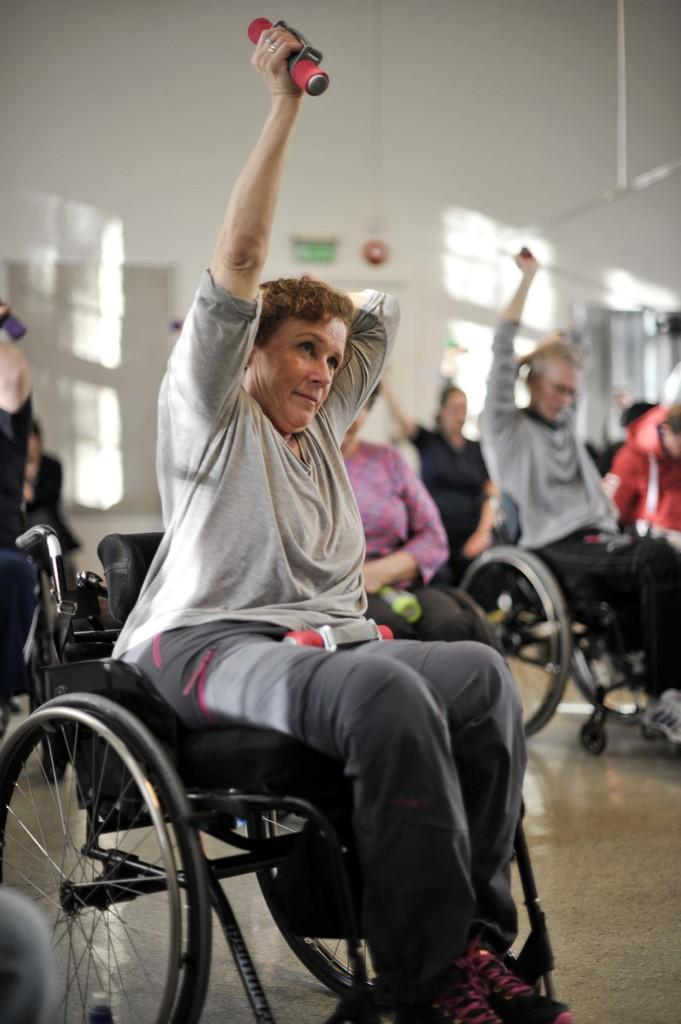What are the people in the image using for mobility? The people in the image are sitting on wheelchairs. Can you describe what one person is holding in the image? One person is holding a red object. How would you describe the overall clarity of the image? The image is slightly blurry in the background. What type of glue is being used to fix the glove in the image? There is no glue or glove present in the image. How many crackers are visible on the wheelchair in the image? There are no crackers visible in the image. 